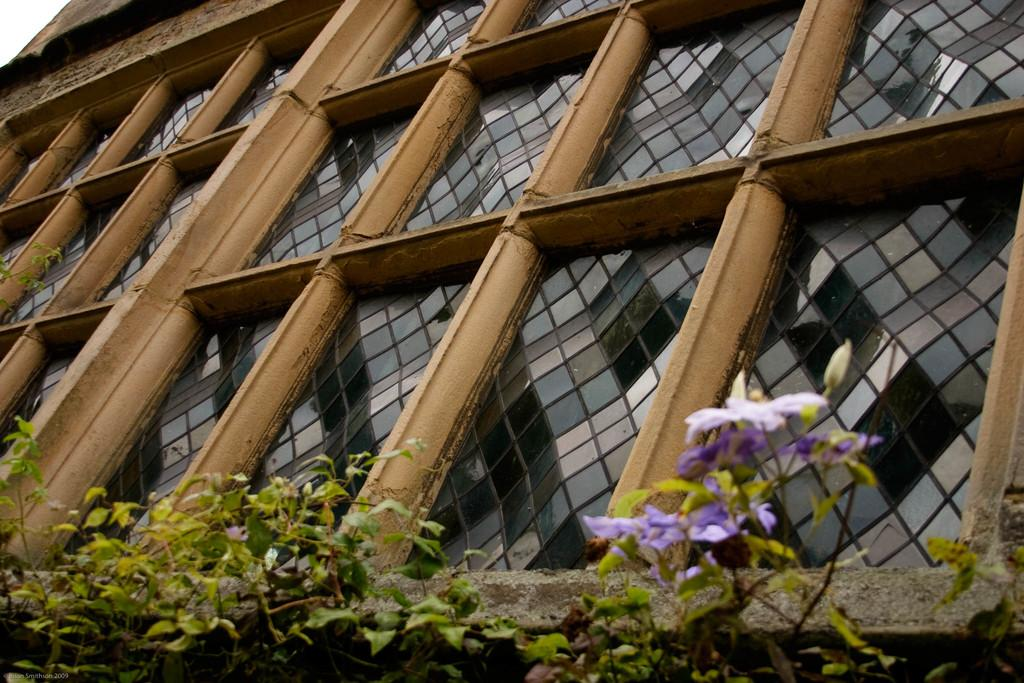What type of structure is visible in the image? There is a building wall in the image. What material is used for the frame on the building wall? The building wall has a wooden frame. What is contained within the wooden frame? The wooden frame contains glasses. What type of vegetation is present in the image? There are plants and flowers in the image. What color are the flowers in the image? The flowers are violet in color. What is the weight of the guitar in the image? There is no guitar present in the image. 